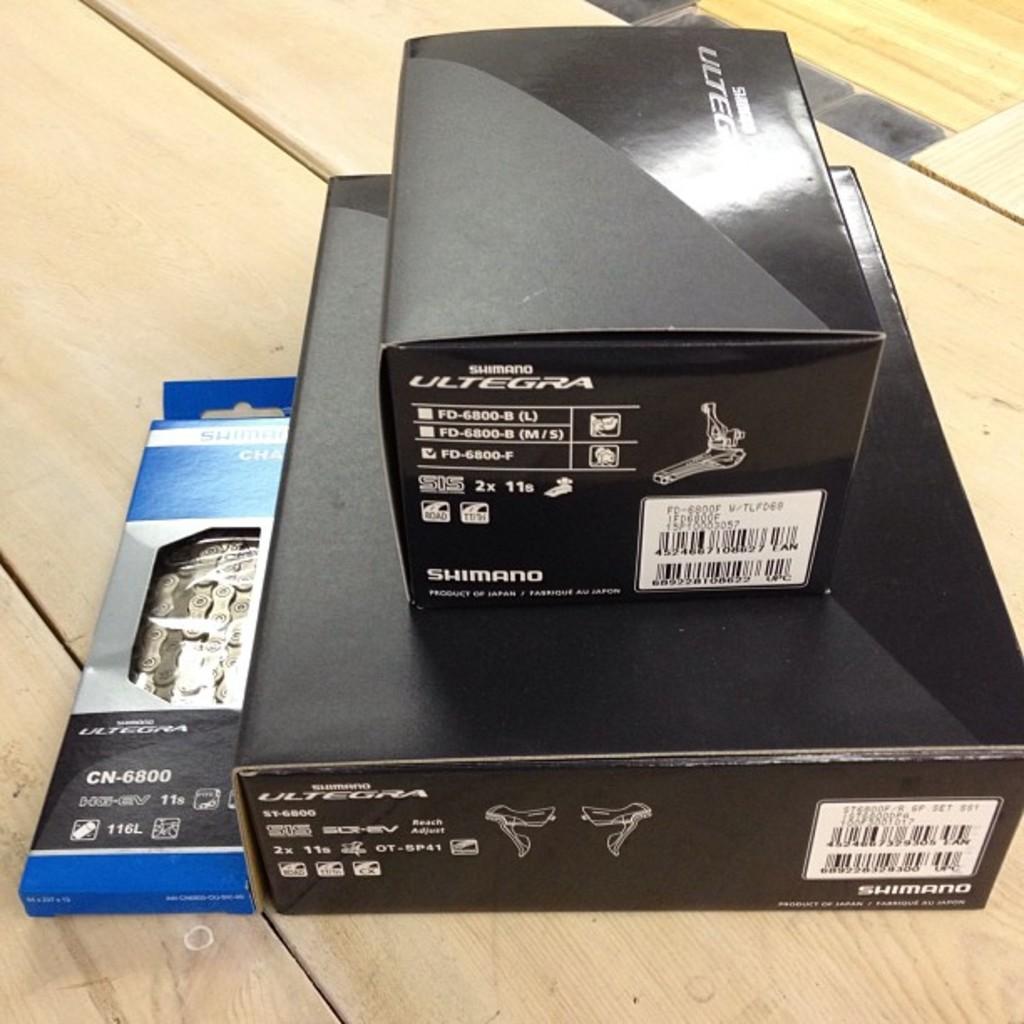What brand products are these?
Give a very brief answer. Ultegra. What is the model number of the remote on the left?
Make the answer very short. Cn-6800. 